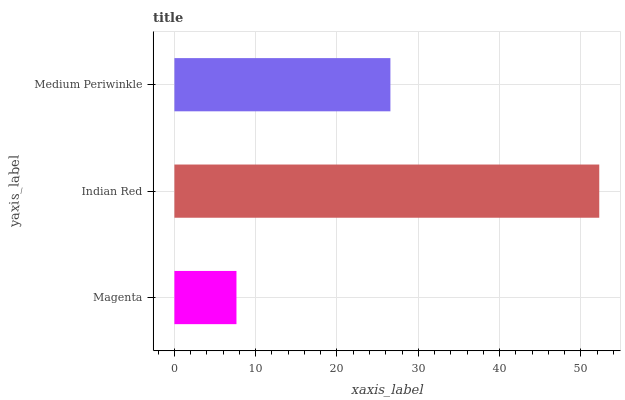Is Magenta the minimum?
Answer yes or no. Yes. Is Indian Red the maximum?
Answer yes or no. Yes. Is Medium Periwinkle the minimum?
Answer yes or no. No. Is Medium Periwinkle the maximum?
Answer yes or no. No. Is Indian Red greater than Medium Periwinkle?
Answer yes or no. Yes. Is Medium Periwinkle less than Indian Red?
Answer yes or no. Yes. Is Medium Periwinkle greater than Indian Red?
Answer yes or no. No. Is Indian Red less than Medium Periwinkle?
Answer yes or no. No. Is Medium Periwinkle the high median?
Answer yes or no. Yes. Is Medium Periwinkle the low median?
Answer yes or no. Yes. Is Indian Red the high median?
Answer yes or no. No. Is Indian Red the low median?
Answer yes or no. No. 